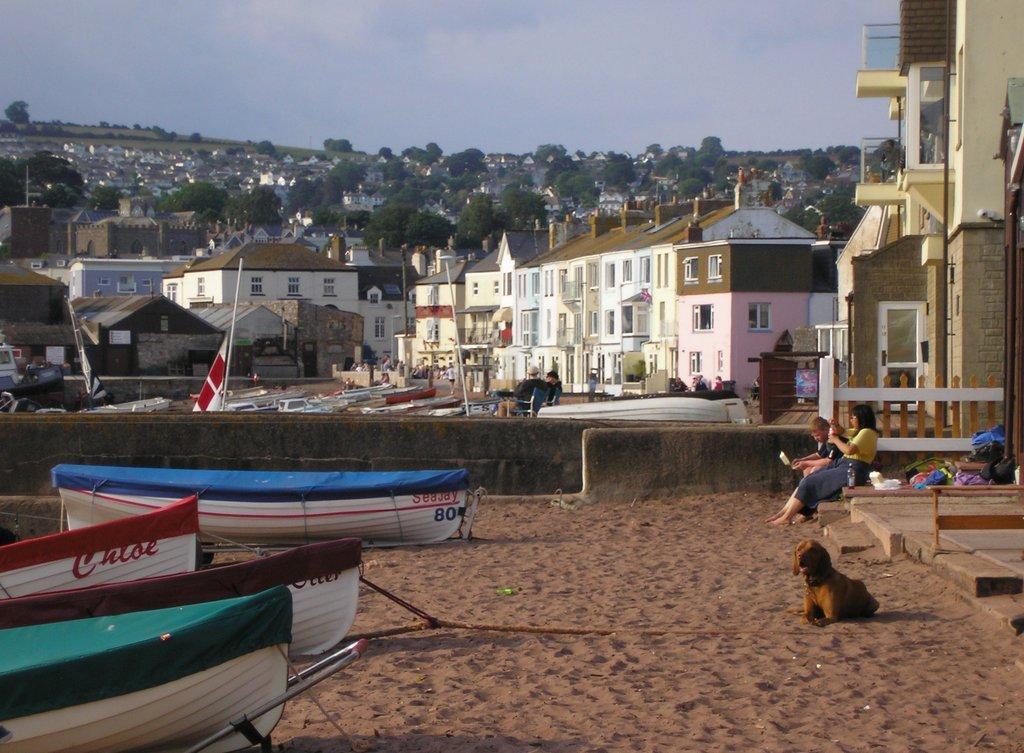Please provide a concise description of this image. In this image there are few boats on the land. Few persons are sitting on the floor. A dog is sitting on the land. Few persons are sitting on the chairs. There is a wall. Behind there are few boats. Background there are few buildings and trees. Top of the image there is sky. 